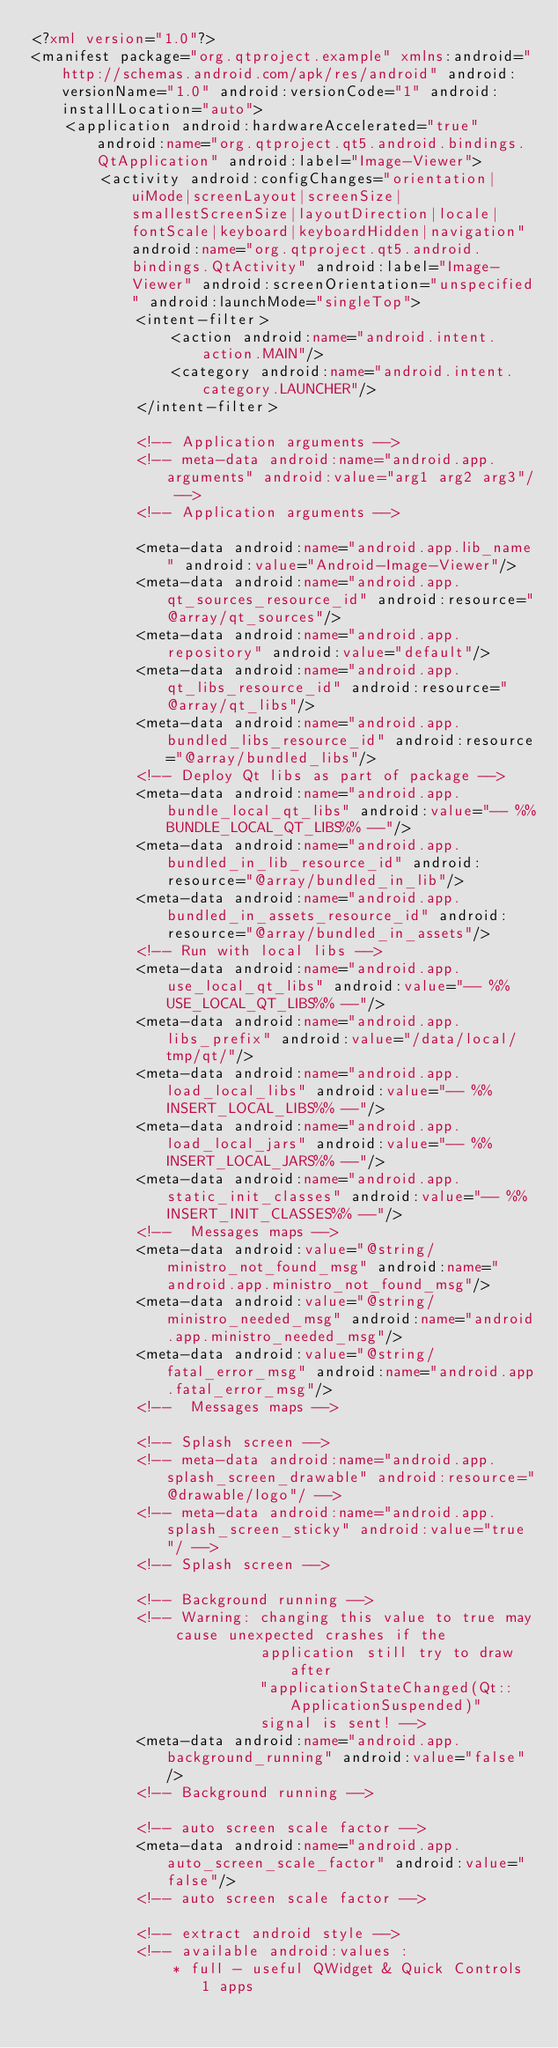Convert code to text. <code><loc_0><loc_0><loc_500><loc_500><_XML_><?xml version="1.0"?>
<manifest package="org.qtproject.example" xmlns:android="http://schemas.android.com/apk/res/android" android:versionName="1.0" android:versionCode="1" android:installLocation="auto">
    <application android:hardwareAccelerated="true" android:name="org.qtproject.qt5.android.bindings.QtApplication" android:label="Image-Viewer">
        <activity android:configChanges="orientation|uiMode|screenLayout|screenSize|smallestScreenSize|layoutDirection|locale|fontScale|keyboard|keyboardHidden|navigation" android:name="org.qtproject.qt5.android.bindings.QtActivity" android:label="Image-Viewer" android:screenOrientation="unspecified" android:launchMode="singleTop">
            <intent-filter>
                <action android:name="android.intent.action.MAIN"/>
                <category android:name="android.intent.category.LAUNCHER"/>
            </intent-filter>

            <!-- Application arguments -->
            <!-- meta-data android:name="android.app.arguments" android:value="arg1 arg2 arg3"/ -->
            <!-- Application arguments -->

            <meta-data android:name="android.app.lib_name" android:value="Android-Image-Viewer"/>
            <meta-data android:name="android.app.qt_sources_resource_id" android:resource="@array/qt_sources"/>
            <meta-data android:name="android.app.repository" android:value="default"/>
            <meta-data android:name="android.app.qt_libs_resource_id" android:resource="@array/qt_libs"/>
            <meta-data android:name="android.app.bundled_libs_resource_id" android:resource="@array/bundled_libs"/>
            <!-- Deploy Qt libs as part of package -->
            <meta-data android:name="android.app.bundle_local_qt_libs" android:value="-- %%BUNDLE_LOCAL_QT_LIBS%% --"/>
            <meta-data android:name="android.app.bundled_in_lib_resource_id" android:resource="@array/bundled_in_lib"/>
            <meta-data android:name="android.app.bundled_in_assets_resource_id" android:resource="@array/bundled_in_assets"/>
            <!-- Run with local libs -->
            <meta-data android:name="android.app.use_local_qt_libs" android:value="-- %%USE_LOCAL_QT_LIBS%% --"/>
            <meta-data android:name="android.app.libs_prefix" android:value="/data/local/tmp/qt/"/>
            <meta-data android:name="android.app.load_local_libs" android:value="-- %%INSERT_LOCAL_LIBS%% --"/>
            <meta-data android:name="android.app.load_local_jars" android:value="-- %%INSERT_LOCAL_JARS%% --"/>
            <meta-data android:name="android.app.static_init_classes" android:value="-- %%INSERT_INIT_CLASSES%% --"/>
            <!--  Messages maps -->
            <meta-data android:value="@string/ministro_not_found_msg" android:name="android.app.ministro_not_found_msg"/>
            <meta-data android:value="@string/ministro_needed_msg" android:name="android.app.ministro_needed_msg"/>
            <meta-data android:value="@string/fatal_error_msg" android:name="android.app.fatal_error_msg"/>
            <!--  Messages maps -->

            <!-- Splash screen -->
            <!-- meta-data android:name="android.app.splash_screen_drawable" android:resource="@drawable/logo"/ -->
            <!-- meta-data android:name="android.app.splash_screen_sticky" android:value="true"/ -->
            <!-- Splash screen -->

            <!-- Background running -->
            <!-- Warning: changing this value to true may cause unexpected crashes if the
                          application still try to draw after
                          "applicationStateChanged(Qt::ApplicationSuspended)"
                          signal is sent! -->
            <meta-data android:name="android.app.background_running" android:value="false"/>
            <!-- Background running -->

            <!-- auto screen scale factor -->
            <meta-data android:name="android.app.auto_screen_scale_factor" android:value="false"/>
            <!-- auto screen scale factor -->

            <!-- extract android style -->
            <!-- available android:values :
                * full - useful QWidget & Quick Controls 1 apps</code> 